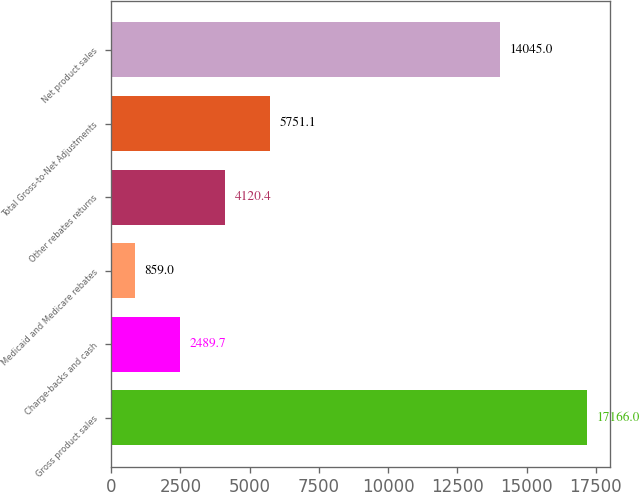Convert chart. <chart><loc_0><loc_0><loc_500><loc_500><bar_chart><fcel>Gross product sales<fcel>Charge-backs and cash<fcel>Medicaid and Medicare rebates<fcel>Other rebates returns<fcel>Total Gross-to-Net Adjustments<fcel>Net product sales<nl><fcel>17166<fcel>2489.7<fcel>859<fcel>4120.4<fcel>5751.1<fcel>14045<nl></chart> 